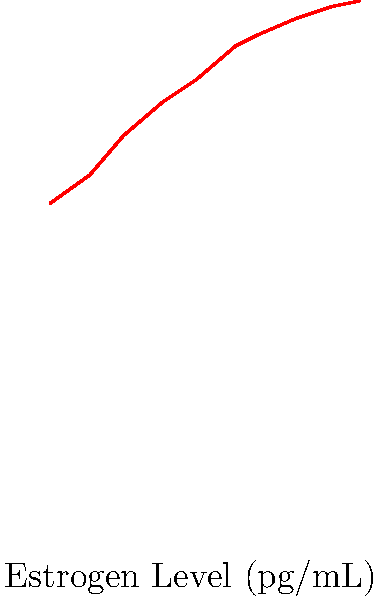Analyze the scatter plot showing the relationship between estrogen levels and muscle strength in female athletes. What type of correlation does this graph suggest, and how might this information inform training strategies for female athletes throughout their menstrual cycle? To analyze the correlation and its implications:

1. Observe the overall trend: As estrogen levels increase, muscle strength also increases.

2. Identify the correlation type:
   - Points form an upward trend from left to right
   - Relationship appears to be positive and relatively strong

3. Quantify the correlation:
   - Points closely follow a line, suggesting a strong positive correlation
   - Correlation coefficient would likely be close to +1

4. Physiological interpretation:
   - Higher estrogen levels are associated with increased muscle strength
   - This aligns with research showing estrogen's role in muscle protein synthesis and recovery

5. Implications for training strategies:
   - Coaches might consider timing high-intensity strength training during high-estrogen phases
   - Recovery periods might be shortened during high-estrogen phases
   - Lower intensity training might be more appropriate during low-estrogen phases

6. Feminist perspective:
   - This data challenges the notion that female hormones are detrimental to athletic performance
   - It supports the idea of tailoring training to female physiology rather than applying male-centric approaches

7. Limitations to consider:
   - Correlation does not imply causation
   - Other factors (e.g., nutrition, sleep) may influence this relationship
   - Individual variations should be considered when applying these findings
Answer: Strong positive correlation; suggests tailoring training intensity to menstrual cycle phases for optimal performance. 